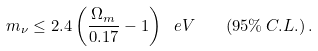Convert formula to latex. <formula><loc_0><loc_0><loc_500><loc_500>m _ { \nu } \leq 2 . 4 \left ( \frac { \Omega _ { m } } { 0 . 1 7 } - 1 \right ) \ e V \quad ( 9 5 \% \, C . L . ) \, .</formula> 